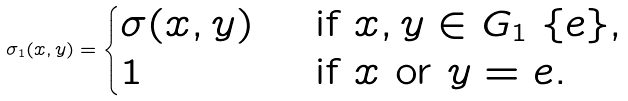<formula> <loc_0><loc_0><loc_500><loc_500>\sigma _ { 1 } ( x , y ) = \begin{cases} \sigma ( x , y ) & \text { if } x , y \in G _ { 1 } \ \{ e \} , \\ 1 & \text { if $x$ or $y=e$} . \end{cases}</formula> 